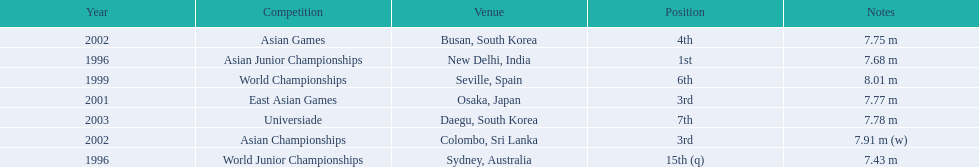Which competition did huang le achieve 3rd place? East Asian Games. Which competition did he achieve 4th place? Asian Games. When did he achieve 1st place? Asian Junior Championships. 